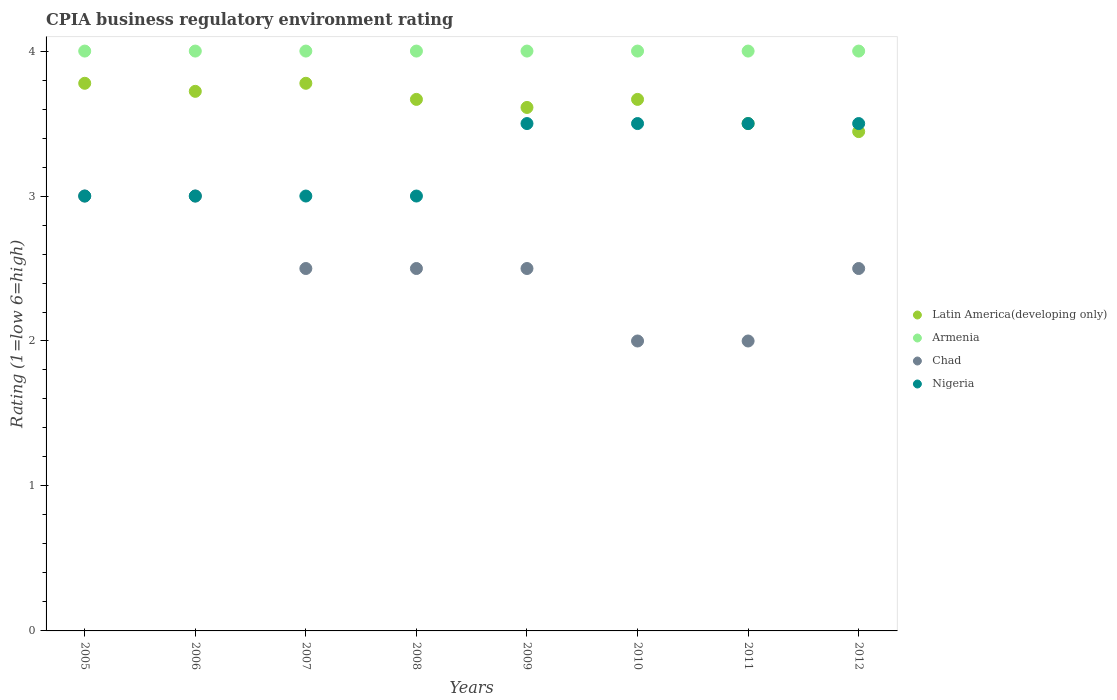What is the CPIA rating in Nigeria in 2009?
Keep it short and to the point. 3.5. Across all years, what is the maximum CPIA rating in Latin America(developing only)?
Your answer should be very brief. 3.78. In which year was the CPIA rating in Chad maximum?
Your answer should be very brief. 2005. In which year was the CPIA rating in Chad minimum?
Keep it short and to the point. 2010. What is the total CPIA rating in Latin America(developing only) in the graph?
Offer a very short reply. 29.17. What is the difference between the CPIA rating in Chad in 2007 and that in 2008?
Give a very brief answer. 0. What is the difference between the CPIA rating in Nigeria in 2011 and the CPIA rating in Armenia in 2005?
Your response must be concise. -0.5. In how many years, is the CPIA rating in Armenia greater than 3.2?
Your answer should be compact. 8. What is the difference between the highest and the second highest CPIA rating in Nigeria?
Offer a very short reply. 0. What is the difference between the highest and the lowest CPIA rating in Chad?
Provide a succinct answer. 1. In how many years, is the CPIA rating in Armenia greater than the average CPIA rating in Armenia taken over all years?
Ensure brevity in your answer.  0. Is the sum of the CPIA rating in Chad in 2008 and 2011 greater than the maximum CPIA rating in Armenia across all years?
Keep it short and to the point. Yes. Is it the case that in every year, the sum of the CPIA rating in Latin America(developing only) and CPIA rating in Armenia  is greater than the CPIA rating in Nigeria?
Your answer should be very brief. Yes. Is the CPIA rating in Chad strictly greater than the CPIA rating in Nigeria over the years?
Offer a terse response. No. Is the CPIA rating in Nigeria strictly less than the CPIA rating in Latin America(developing only) over the years?
Provide a short and direct response. No. How many dotlines are there?
Keep it short and to the point. 4. What is the difference between two consecutive major ticks on the Y-axis?
Give a very brief answer. 1. Are the values on the major ticks of Y-axis written in scientific E-notation?
Give a very brief answer. No. How are the legend labels stacked?
Your answer should be very brief. Vertical. What is the title of the graph?
Offer a terse response. CPIA business regulatory environment rating. What is the label or title of the X-axis?
Provide a short and direct response. Years. What is the Rating (1=low 6=high) in Latin America(developing only) in 2005?
Offer a terse response. 3.78. What is the Rating (1=low 6=high) of Armenia in 2005?
Keep it short and to the point. 4. What is the Rating (1=low 6=high) in Nigeria in 2005?
Ensure brevity in your answer.  3. What is the Rating (1=low 6=high) in Latin America(developing only) in 2006?
Provide a short and direct response. 3.72. What is the Rating (1=low 6=high) in Nigeria in 2006?
Make the answer very short. 3. What is the Rating (1=low 6=high) of Latin America(developing only) in 2007?
Give a very brief answer. 3.78. What is the Rating (1=low 6=high) in Chad in 2007?
Your answer should be compact. 2.5. What is the Rating (1=low 6=high) in Nigeria in 2007?
Offer a terse response. 3. What is the Rating (1=low 6=high) in Latin America(developing only) in 2008?
Provide a succinct answer. 3.67. What is the Rating (1=low 6=high) of Armenia in 2008?
Provide a succinct answer. 4. What is the Rating (1=low 6=high) in Chad in 2008?
Make the answer very short. 2.5. What is the Rating (1=low 6=high) of Latin America(developing only) in 2009?
Keep it short and to the point. 3.61. What is the Rating (1=low 6=high) in Nigeria in 2009?
Your response must be concise. 3.5. What is the Rating (1=low 6=high) in Latin America(developing only) in 2010?
Offer a very short reply. 3.67. What is the Rating (1=low 6=high) of Chad in 2010?
Provide a succinct answer. 2. What is the Rating (1=low 6=high) in Armenia in 2011?
Offer a very short reply. 4. What is the Rating (1=low 6=high) in Nigeria in 2011?
Your response must be concise. 3.5. What is the Rating (1=low 6=high) in Latin America(developing only) in 2012?
Make the answer very short. 3.44. What is the Rating (1=low 6=high) of Nigeria in 2012?
Offer a terse response. 3.5. Across all years, what is the maximum Rating (1=low 6=high) in Latin America(developing only)?
Your response must be concise. 3.78. Across all years, what is the maximum Rating (1=low 6=high) in Armenia?
Offer a very short reply. 4. Across all years, what is the maximum Rating (1=low 6=high) in Nigeria?
Give a very brief answer. 3.5. Across all years, what is the minimum Rating (1=low 6=high) of Latin America(developing only)?
Offer a very short reply. 3.44. Across all years, what is the minimum Rating (1=low 6=high) of Armenia?
Provide a short and direct response. 4. Across all years, what is the minimum Rating (1=low 6=high) in Nigeria?
Keep it short and to the point. 3. What is the total Rating (1=low 6=high) in Latin America(developing only) in the graph?
Provide a short and direct response. 29.17. What is the total Rating (1=low 6=high) in Chad in the graph?
Provide a short and direct response. 20. What is the total Rating (1=low 6=high) in Nigeria in the graph?
Offer a terse response. 26. What is the difference between the Rating (1=low 6=high) in Latin America(developing only) in 2005 and that in 2006?
Provide a short and direct response. 0.06. What is the difference between the Rating (1=low 6=high) of Armenia in 2005 and that in 2006?
Provide a succinct answer. 0. What is the difference between the Rating (1=low 6=high) in Chad in 2005 and that in 2006?
Ensure brevity in your answer.  0. What is the difference between the Rating (1=low 6=high) in Nigeria in 2005 and that in 2006?
Make the answer very short. 0. What is the difference between the Rating (1=low 6=high) of Chad in 2005 and that in 2007?
Give a very brief answer. 0.5. What is the difference between the Rating (1=low 6=high) of Armenia in 2005 and that in 2008?
Your response must be concise. 0. What is the difference between the Rating (1=low 6=high) of Nigeria in 2005 and that in 2008?
Keep it short and to the point. 0. What is the difference between the Rating (1=low 6=high) of Latin America(developing only) in 2005 and that in 2009?
Provide a succinct answer. 0.17. What is the difference between the Rating (1=low 6=high) in Chad in 2005 and that in 2009?
Offer a very short reply. 0.5. What is the difference between the Rating (1=low 6=high) of Nigeria in 2005 and that in 2009?
Your answer should be compact. -0.5. What is the difference between the Rating (1=low 6=high) of Armenia in 2005 and that in 2010?
Provide a short and direct response. 0. What is the difference between the Rating (1=low 6=high) in Nigeria in 2005 and that in 2010?
Keep it short and to the point. -0.5. What is the difference between the Rating (1=low 6=high) in Latin America(developing only) in 2005 and that in 2011?
Your answer should be very brief. 0.28. What is the difference between the Rating (1=low 6=high) of Armenia in 2005 and that in 2011?
Your answer should be compact. 0. What is the difference between the Rating (1=low 6=high) of Armenia in 2005 and that in 2012?
Offer a very short reply. 0. What is the difference between the Rating (1=low 6=high) of Chad in 2005 and that in 2012?
Your answer should be very brief. 0.5. What is the difference between the Rating (1=low 6=high) of Nigeria in 2005 and that in 2012?
Your answer should be compact. -0.5. What is the difference between the Rating (1=low 6=high) of Latin America(developing only) in 2006 and that in 2007?
Provide a short and direct response. -0.06. What is the difference between the Rating (1=low 6=high) in Latin America(developing only) in 2006 and that in 2008?
Make the answer very short. 0.06. What is the difference between the Rating (1=low 6=high) in Chad in 2006 and that in 2008?
Offer a terse response. 0.5. What is the difference between the Rating (1=low 6=high) in Latin America(developing only) in 2006 and that in 2009?
Offer a terse response. 0.11. What is the difference between the Rating (1=low 6=high) of Armenia in 2006 and that in 2009?
Make the answer very short. 0. What is the difference between the Rating (1=low 6=high) of Chad in 2006 and that in 2009?
Your answer should be very brief. 0.5. What is the difference between the Rating (1=low 6=high) of Nigeria in 2006 and that in 2009?
Your response must be concise. -0.5. What is the difference between the Rating (1=low 6=high) of Latin America(developing only) in 2006 and that in 2010?
Give a very brief answer. 0.06. What is the difference between the Rating (1=low 6=high) in Latin America(developing only) in 2006 and that in 2011?
Keep it short and to the point. 0.22. What is the difference between the Rating (1=low 6=high) in Chad in 2006 and that in 2011?
Make the answer very short. 1. What is the difference between the Rating (1=low 6=high) in Nigeria in 2006 and that in 2011?
Offer a terse response. -0.5. What is the difference between the Rating (1=low 6=high) in Latin America(developing only) in 2006 and that in 2012?
Your response must be concise. 0.28. What is the difference between the Rating (1=low 6=high) in Chad in 2006 and that in 2012?
Your answer should be compact. 0.5. What is the difference between the Rating (1=low 6=high) in Nigeria in 2006 and that in 2012?
Offer a terse response. -0.5. What is the difference between the Rating (1=low 6=high) in Latin America(developing only) in 2007 and that in 2008?
Give a very brief answer. 0.11. What is the difference between the Rating (1=low 6=high) of Latin America(developing only) in 2007 and that in 2009?
Give a very brief answer. 0.17. What is the difference between the Rating (1=low 6=high) of Armenia in 2007 and that in 2009?
Ensure brevity in your answer.  0. What is the difference between the Rating (1=low 6=high) in Armenia in 2007 and that in 2010?
Your answer should be compact. 0. What is the difference between the Rating (1=low 6=high) in Latin America(developing only) in 2007 and that in 2011?
Give a very brief answer. 0.28. What is the difference between the Rating (1=low 6=high) of Chad in 2007 and that in 2011?
Provide a short and direct response. 0.5. What is the difference between the Rating (1=low 6=high) in Nigeria in 2007 and that in 2011?
Ensure brevity in your answer.  -0.5. What is the difference between the Rating (1=low 6=high) of Armenia in 2007 and that in 2012?
Your response must be concise. 0. What is the difference between the Rating (1=low 6=high) in Latin America(developing only) in 2008 and that in 2009?
Provide a succinct answer. 0.06. What is the difference between the Rating (1=low 6=high) of Nigeria in 2008 and that in 2009?
Offer a very short reply. -0.5. What is the difference between the Rating (1=low 6=high) in Latin America(developing only) in 2008 and that in 2010?
Keep it short and to the point. 0. What is the difference between the Rating (1=low 6=high) of Chad in 2008 and that in 2010?
Your response must be concise. 0.5. What is the difference between the Rating (1=low 6=high) in Nigeria in 2008 and that in 2011?
Your response must be concise. -0.5. What is the difference between the Rating (1=low 6=high) of Latin America(developing only) in 2008 and that in 2012?
Offer a very short reply. 0.22. What is the difference between the Rating (1=low 6=high) of Armenia in 2008 and that in 2012?
Ensure brevity in your answer.  0. What is the difference between the Rating (1=low 6=high) of Chad in 2008 and that in 2012?
Provide a short and direct response. 0. What is the difference between the Rating (1=low 6=high) in Latin America(developing only) in 2009 and that in 2010?
Give a very brief answer. -0.06. What is the difference between the Rating (1=low 6=high) of Nigeria in 2009 and that in 2010?
Your response must be concise. 0. What is the difference between the Rating (1=low 6=high) of Latin America(developing only) in 2009 and that in 2012?
Offer a very short reply. 0.17. What is the difference between the Rating (1=low 6=high) of Armenia in 2009 and that in 2012?
Keep it short and to the point. 0. What is the difference between the Rating (1=low 6=high) of Chad in 2009 and that in 2012?
Give a very brief answer. 0. What is the difference between the Rating (1=low 6=high) in Armenia in 2010 and that in 2011?
Offer a very short reply. 0. What is the difference between the Rating (1=low 6=high) of Chad in 2010 and that in 2011?
Offer a terse response. 0. What is the difference between the Rating (1=low 6=high) of Nigeria in 2010 and that in 2011?
Your response must be concise. 0. What is the difference between the Rating (1=low 6=high) in Latin America(developing only) in 2010 and that in 2012?
Your answer should be very brief. 0.22. What is the difference between the Rating (1=low 6=high) in Armenia in 2010 and that in 2012?
Your answer should be very brief. 0. What is the difference between the Rating (1=low 6=high) of Chad in 2010 and that in 2012?
Offer a terse response. -0.5. What is the difference between the Rating (1=low 6=high) of Nigeria in 2010 and that in 2012?
Provide a succinct answer. 0. What is the difference between the Rating (1=low 6=high) in Latin America(developing only) in 2011 and that in 2012?
Your response must be concise. 0.06. What is the difference between the Rating (1=low 6=high) of Nigeria in 2011 and that in 2012?
Provide a succinct answer. 0. What is the difference between the Rating (1=low 6=high) in Latin America(developing only) in 2005 and the Rating (1=low 6=high) in Armenia in 2006?
Your answer should be very brief. -0.22. What is the difference between the Rating (1=low 6=high) in Armenia in 2005 and the Rating (1=low 6=high) in Chad in 2006?
Provide a short and direct response. 1. What is the difference between the Rating (1=low 6=high) of Chad in 2005 and the Rating (1=low 6=high) of Nigeria in 2006?
Offer a very short reply. 0. What is the difference between the Rating (1=low 6=high) in Latin America(developing only) in 2005 and the Rating (1=low 6=high) in Armenia in 2007?
Provide a succinct answer. -0.22. What is the difference between the Rating (1=low 6=high) in Latin America(developing only) in 2005 and the Rating (1=low 6=high) in Chad in 2007?
Provide a succinct answer. 1.28. What is the difference between the Rating (1=low 6=high) in Latin America(developing only) in 2005 and the Rating (1=low 6=high) in Nigeria in 2007?
Offer a very short reply. 0.78. What is the difference between the Rating (1=low 6=high) in Armenia in 2005 and the Rating (1=low 6=high) in Chad in 2007?
Your response must be concise. 1.5. What is the difference between the Rating (1=low 6=high) of Armenia in 2005 and the Rating (1=low 6=high) of Nigeria in 2007?
Keep it short and to the point. 1. What is the difference between the Rating (1=low 6=high) of Latin America(developing only) in 2005 and the Rating (1=low 6=high) of Armenia in 2008?
Keep it short and to the point. -0.22. What is the difference between the Rating (1=low 6=high) of Latin America(developing only) in 2005 and the Rating (1=low 6=high) of Chad in 2008?
Give a very brief answer. 1.28. What is the difference between the Rating (1=low 6=high) in Latin America(developing only) in 2005 and the Rating (1=low 6=high) in Nigeria in 2008?
Offer a very short reply. 0.78. What is the difference between the Rating (1=low 6=high) of Armenia in 2005 and the Rating (1=low 6=high) of Chad in 2008?
Keep it short and to the point. 1.5. What is the difference between the Rating (1=low 6=high) of Latin America(developing only) in 2005 and the Rating (1=low 6=high) of Armenia in 2009?
Ensure brevity in your answer.  -0.22. What is the difference between the Rating (1=low 6=high) of Latin America(developing only) in 2005 and the Rating (1=low 6=high) of Chad in 2009?
Provide a short and direct response. 1.28. What is the difference between the Rating (1=low 6=high) of Latin America(developing only) in 2005 and the Rating (1=low 6=high) of Nigeria in 2009?
Your answer should be very brief. 0.28. What is the difference between the Rating (1=low 6=high) of Armenia in 2005 and the Rating (1=low 6=high) of Chad in 2009?
Keep it short and to the point. 1.5. What is the difference between the Rating (1=low 6=high) in Chad in 2005 and the Rating (1=low 6=high) in Nigeria in 2009?
Give a very brief answer. -0.5. What is the difference between the Rating (1=low 6=high) in Latin America(developing only) in 2005 and the Rating (1=low 6=high) in Armenia in 2010?
Keep it short and to the point. -0.22. What is the difference between the Rating (1=low 6=high) of Latin America(developing only) in 2005 and the Rating (1=low 6=high) of Chad in 2010?
Your answer should be compact. 1.78. What is the difference between the Rating (1=low 6=high) of Latin America(developing only) in 2005 and the Rating (1=low 6=high) of Nigeria in 2010?
Your answer should be compact. 0.28. What is the difference between the Rating (1=low 6=high) of Armenia in 2005 and the Rating (1=low 6=high) of Chad in 2010?
Keep it short and to the point. 2. What is the difference between the Rating (1=low 6=high) in Latin America(developing only) in 2005 and the Rating (1=low 6=high) in Armenia in 2011?
Offer a very short reply. -0.22. What is the difference between the Rating (1=low 6=high) in Latin America(developing only) in 2005 and the Rating (1=low 6=high) in Chad in 2011?
Provide a short and direct response. 1.78. What is the difference between the Rating (1=low 6=high) of Latin America(developing only) in 2005 and the Rating (1=low 6=high) of Nigeria in 2011?
Make the answer very short. 0.28. What is the difference between the Rating (1=low 6=high) of Armenia in 2005 and the Rating (1=low 6=high) of Chad in 2011?
Provide a succinct answer. 2. What is the difference between the Rating (1=low 6=high) in Chad in 2005 and the Rating (1=low 6=high) in Nigeria in 2011?
Keep it short and to the point. -0.5. What is the difference between the Rating (1=low 6=high) of Latin America(developing only) in 2005 and the Rating (1=low 6=high) of Armenia in 2012?
Offer a terse response. -0.22. What is the difference between the Rating (1=low 6=high) in Latin America(developing only) in 2005 and the Rating (1=low 6=high) in Chad in 2012?
Offer a terse response. 1.28. What is the difference between the Rating (1=low 6=high) of Latin America(developing only) in 2005 and the Rating (1=low 6=high) of Nigeria in 2012?
Your answer should be compact. 0.28. What is the difference between the Rating (1=low 6=high) in Armenia in 2005 and the Rating (1=low 6=high) in Chad in 2012?
Give a very brief answer. 1.5. What is the difference between the Rating (1=low 6=high) of Armenia in 2005 and the Rating (1=low 6=high) of Nigeria in 2012?
Your answer should be very brief. 0.5. What is the difference between the Rating (1=low 6=high) of Chad in 2005 and the Rating (1=low 6=high) of Nigeria in 2012?
Offer a very short reply. -0.5. What is the difference between the Rating (1=low 6=high) in Latin America(developing only) in 2006 and the Rating (1=low 6=high) in Armenia in 2007?
Your answer should be very brief. -0.28. What is the difference between the Rating (1=low 6=high) of Latin America(developing only) in 2006 and the Rating (1=low 6=high) of Chad in 2007?
Provide a succinct answer. 1.22. What is the difference between the Rating (1=low 6=high) in Latin America(developing only) in 2006 and the Rating (1=low 6=high) in Nigeria in 2007?
Offer a terse response. 0.72. What is the difference between the Rating (1=low 6=high) in Armenia in 2006 and the Rating (1=low 6=high) in Nigeria in 2007?
Your answer should be very brief. 1. What is the difference between the Rating (1=low 6=high) in Latin America(developing only) in 2006 and the Rating (1=low 6=high) in Armenia in 2008?
Provide a short and direct response. -0.28. What is the difference between the Rating (1=low 6=high) of Latin America(developing only) in 2006 and the Rating (1=low 6=high) of Chad in 2008?
Ensure brevity in your answer.  1.22. What is the difference between the Rating (1=low 6=high) in Latin America(developing only) in 2006 and the Rating (1=low 6=high) in Nigeria in 2008?
Your answer should be very brief. 0.72. What is the difference between the Rating (1=low 6=high) of Armenia in 2006 and the Rating (1=low 6=high) of Chad in 2008?
Make the answer very short. 1.5. What is the difference between the Rating (1=low 6=high) in Latin America(developing only) in 2006 and the Rating (1=low 6=high) in Armenia in 2009?
Provide a short and direct response. -0.28. What is the difference between the Rating (1=low 6=high) in Latin America(developing only) in 2006 and the Rating (1=low 6=high) in Chad in 2009?
Make the answer very short. 1.22. What is the difference between the Rating (1=low 6=high) in Latin America(developing only) in 2006 and the Rating (1=low 6=high) in Nigeria in 2009?
Give a very brief answer. 0.22. What is the difference between the Rating (1=low 6=high) of Chad in 2006 and the Rating (1=low 6=high) of Nigeria in 2009?
Offer a terse response. -0.5. What is the difference between the Rating (1=low 6=high) in Latin America(developing only) in 2006 and the Rating (1=low 6=high) in Armenia in 2010?
Provide a succinct answer. -0.28. What is the difference between the Rating (1=low 6=high) in Latin America(developing only) in 2006 and the Rating (1=low 6=high) in Chad in 2010?
Provide a succinct answer. 1.72. What is the difference between the Rating (1=low 6=high) in Latin America(developing only) in 2006 and the Rating (1=low 6=high) in Nigeria in 2010?
Keep it short and to the point. 0.22. What is the difference between the Rating (1=low 6=high) of Chad in 2006 and the Rating (1=low 6=high) of Nigeria in 2010?
Your response must be concise. -0.5. What is the difference between the Rating (1=low 6=high) of Latin America(developing only) in 2006 and the Rating (1=low 6=high) of Armenia in 2011?
Your response must be concise. -0.28. What is the difference between the Rating (1=low 6=high) of Latin America(developing only) in 2006 and the Rating (1=low 6=high) of Chad in 2011?
Offer a very short reply. 1.72. What is the difference between the Rating (1=low 6=high) of Latin America(developing only) in 2006 and the Rating (1=low 6=high) of Nigeria in 2011?
Give a very brief answer. 0.22. What is the difference between the Rating (1=low 6=high) of Armenia in 2006 and the Rating (1=low 6=high) of Chad in 2011?
Your answer should be compact. 2. What is the difference between the Rating (1=low 6=high) of Latin America(developing only) in 2006 and the Rating (1=low 6=high) of Armenia in 2012?
Provide a succinct answer. -0.28. What is the difference between the Rating (1=low 6=high) in Latin America(developing only) in 2006 and the Rating (1=low 6=high) in Chad in 2012?
Make the answer very short. 1.22. What is the difference between the Rating (1=low 6=high) in Latin America(developing only) in 2006 and the Rating (1=low 6=high) in Nigeria in 2012?
Ensure brevity in your answer.  0.22. What is the difference between the Rating (1=low 6=high) of Armenia in 2006 and the Rating (1=low 6=high) of Chad in 2012?
Your answer should be very brief. 1.5. What is the difference between the Rating (1=low 6=high) of Chad in 2006 and the Rating (1=low 6=high) of Nigeria in 2012?
Offer a very short reply. -0.5. What is the difference between the Rating (1=low 6=high) of Latin America(developing only) in 2007 and the Rating (1=low 6=high) of Armenia in 2008?
Offer a very short reply. -0.22. What is the difference between the Rating (1=low 6=high) of Latin America(developing only) in 2007 and the Rating (1=low 6=high) of Chad in 2008?
Provide a succinct answer. 1.28. What is the difference between the Rating (1=low 6=high) in Latin America(developing only) in 2007 and the Rating (1=low 6=high) in Nigeria in 2008?
Make the answer very short. 0.78. What is the difference between the Rating (1=low 6=high) in Armenia in 2007 and the Rating (1=low 6=high) in Nigeria in 2008?
Ensure brevity in your answer.  1. What is the difference between the Rating (1=low 6=high) in Latin America(developing only) in 2007 and the Rating (1=low 6=high) in Armenia in 2009?
Your answer should be very brief. -0.22. What is the difference between the Rating (1=low 6=high) in Latin America(developing only) in 2007 and the Rating (1=low 6=high) in Chad in 2009?
Make the answer very short. 1.28. What is the difference between the Rating (1=low 6=high) in Latin America(developing only) in 2007 and the Rating (1=low 6=high) in Nigeria in 2009?
Your answer should be compact. 0.28. What is the difference between the Rating (1=low 6=high) in Armenia in 2007 and the Rating (1=low 6=high) in Nigeria in 2009?
Provide a short and direct response. 0.5. What is the difference between the Rating (1=low 6=high) in Latin America(developing only) in 2007 and the Rating (1=low 6=high) in Armenia in 2010?
Your response must be concise. -0.22. What is the difference between the Rating (1=low 6=high) of Latin America(developing only) in 2007 and the Rating (1=low 6=high) of Chad in 2010?
Your answer should be very brief. 1.78. What is the difference between the Rating (1=low 6=high) in Latin America(developing only) in 2007 and the Rating (1=low 6=high) in Nigeria in 2010?
Your answer should be compact. 0.28. What is the difference between the Rating (1=low 6=high) in Chad in 2007 and the Rating (1=low 6=high) in Nigeria in 2010?
Keep it short and to the point. -1. What is the difference between the Rating (1=low 6=high) in Latin America(developing only) in 2007 and the Rating (1=low 6=high) in Armenia in 2011?
Provide a succinct answer. -0.22. What is the difference between the Rating (1=low 6=high) of Latin America(developing only) in 2007 and the Rating (1=low 6=high) of Chad in 2011?
Provide a short and direct response. 1.78. What is the difference between the Rating (1=low 6=high) in Latin America(developing only) in 2007 and the Rating (1=low 6=high) in Nigeria in 2011?
Provide a short and direct response. 0.28. What is the difference between the Rating (1=low 6=high) of Armenia in 2007 and the Rating (1=low 6=high) of Chad in 2011?
Provide a short and direct response. 2. What is the difference between the Rating (1=low 6=high) in Chad in 2007 and the Rating (1=low 6=high) in Nigeria in 2011?
Offer a very short reply. -1. What is the difference between the Rating (1=low 6=high) in Latin America(developing only) in 2007 and the Rating (1=low 6=high) in Armenia in 2012?
Your response must be concise. -0.22. What is the difference between the Rating (1=low 6=high) of Latin America(developing only) in 2007 and the Rating (1=low 6=high) of Chad in 2012?
Provide a short and direct response. 1.28. What is the difference between the Rating (1=low 6=high) of Latin America(developing only) in 2007 and the Rating (1=low 6=high) of Nigeria in 2012?
Offer a very short reply. 0.28. What is the difference between the Rating (1=low 6=high) of Armenia in 2007 and the Rating (1=low 6=high) of Chad in 2012?
Make the answer very short. 1.5. What is the difference between the Rating (1=low 6=high) in Armenia in 2007 and the Rating (1=low 6=high) in Nigeria in 2012?
Your answer should be compact. 0.5. What is the difference between the Rating (1=low 6=high) of Chad in 2007 and the Rating (1=low 6=high) of Nigeria in 2012?
Your answer should be compact. -1. What is the difference between the Rating (1=low 6=high) in Latin America(developing only) in 2008 and the Rating (1=low 6=high) in Nigeria in 2009?
Provide a short and direct response. 0.17. What is the difference between the Rating (1=low 6=high) of Armenia in 2008 and the Rating (1=low 6=high) of Nigeria in 2009?
Provide a short and direct response. 0.5. What is the difference between the Rating (1=low 6=high) in Latin America(developing only) in 2008 and the Rating (1=low 6=high) in Armenia in 2010?
Provide a succinct answer. -0.33. What is the difference between the Rating (1=low 6=high) of Armenia in 2008 and the Rating (1=low 6=high) of Chad in 2010?
Provide a short and direct response. 2. What is the difference between the Rating (1=low 6=high) in Armenia in 2008 and the Rating (1=low 6=high) in Nigeria in 2010?
Offer a terse response. 0.5. What is the difference between the Rating (1=low 6=high) of Chad in 2008 and the Rating (1=low 6=high) of Nigeria in 2010?
Provide a short and direct response. -1. What is the difference between the Rating (1=low 6=high) of Latin America(developing only) in 2008 and the Rating (1=low 6=high) of Armenia in 2011?
Offer a very short reply. -0.33. What is the difference between the Rating (1=low 6=high) in Latin America(developing only) in 2008 and the Rating (1=low 6=high) in Nigeria in 2011?
Keep it short and to the point. 0.17. What is the difference between the Rating (1=low 6=high) of Chad in 2008 and the Rating (1=low 6=high) of Nigeria in 2011?
Offer a terse response. -1. What is the difference between the Rating (1=low 6=high) of Latin America(developing only) in 2008 and the Rating (1=low 6=high) of Armenia in 2012?
Give a very brief answer. -0.33. What is the difference between the Rating (1=low 6=high) of Latin America(developing only) in 2008 and the Rating (1=low 6=high) of Nigeria in 2012?
Your response must be concise. 0.17. What is the difference between the Rating (1=low 6=high) in Chad in 2008 and the Rating (1=low 6=high) in Nigeria in 2012?
Your answer should be very brief. -1. What is the difference between the Rating (1=low 6=high) in Latin America(developing only) in 2009 and the Rating (1=low 6=high) in Armenia in 2010?
Give a very brief answer. -0.39. What is the difference between the Rating (1=low 6=high) in Latin America(developing only) in 2009 and the Rating (1=low 6=high) in Chad in 2010?
Offer a very short reply. 1.61. What is the difference between the Rating (1=low 6=high) in Latin America(developing only) in 2009 and the Rating (1=low 6=high) in Nigeria in 2010?
Provide a succinct answer. 0.11. What is the difference between the Rating (1=low 6=high) in Armenia in 2009 and the Rating (1=low 6=high) in Chad in 2010?
Your response must be concise. 2. What is the difference between the Rating (1=low 6=high) of Latin America(developing only) in 2009 and the Rating (1=low 6=high) of Armenia in 2011?
Offer a terse response. -0.39. What is the difference between the Rating (1=low 6=high) of Latin America(developing only) in 2009 and the Rating (1=low 6=high) of Chad in 2011?
Make the answer very short. 1.61. What is the difference between the Rating (1=low 6=high) in Latin America(developing only) in 2009 and the Rating (1=low 6=high) in Nigeria in 2011?
Offer a very short reply. 0.11. What is the difference between the Rating (1=low 6=high) of Chad in 2009 and the Rating (1=low 6=high) of Nigeria in 2011?
Provide a short and direct response. -1. What is the difference between the Rating (1=low 6=high) in Latin America(developing only) in 2009 and the Rating (1=low 6=high) in Armenia in 2012?
Your answer should be very brief. -0.39. What is the difference between the Rating (1=low 6=high) in Latin America(developing only) in 2009 and the Rating (1=low 6=high) in Nigeria in 2012?
Make the answer very short. 0.11. What is the difference between the Rating (1=low 6=high) of Chad in 2009 and the Rating (1=low 6=high) of Nigeria in 2012?
Your answer should be compact. -1. What is the difference between the Rating (1=low 6=high) in Armenia in 2010 and the Rating (1=low 6=high) in Chad in 2011?
Make the answer very short. 2. What is the difference between the Rating (1=low 6=high) of Armenia in 2010 and the Rating (1=low 6=high) of Nigeria in 2011?
Ensure brevity in your answer.  0.5. What is the difference between the Rating (1=low 6=high) in Latin America(developing only) in 2010 and the Rating (1=low 6=high) in Armenia in 2012?
Provide a succinct answer. -0.33. What is the difference between the Rating (1=low 6=high) of Latin America(developing only) in 2010 and the Rating (1=low 6=high) of Chad in 2012?
Your response must be concise. 1.17. What is the difference between the Rating (1=low 6=high) of Latin America(developing only) in 2010 and the Rating (1=low 6=high) of Nigeria in 2012?
Ensure brevity in your answer.  0.17. What is the difference between the Rating (1=low 6=high) in Chad in 2010 and the Rating (1=low 6=high) in Nigeria in 2012?
Your answer should be very brief. -1.5. What is the difference between the Rating (1=low 6=high) of Chad in 2011 and the Rating (1=low 6=high) of Nigeria in 2012?
Your response must be concise. -1.5. What is the average Rating (1=low 6=high) in Latin America(developing only) per year?
Keep it short and to the point. 3.65. What is the average Rating (1=low 6=high) in Chad per year?
Offer a very short reply. 2.5. What is the average Rating (1=low 6=high) in Nigeria per year?
Make the answer very short. 3.25. In the year 2005, what is the difference between the Rating (1=low 6=high) in Latin America(developing only) and Rating (1=low 6=high) in Armenia?
Offer a very short reply. -0.22. In the year 2005, what is the difference between the Rating (1=low 6=high) of Armenia and Rating (1=low 6=high) of Chad?
Provide a succinct answer. 1. In the year 2005, what is the difference between the Rating (1=low 6=high) in Armenia and Rating (1=low 6=high) in Nigeria?
Make the answer very short. 1. In the year 2006, what is the difference between the Rating (1=low 6=high) in Latin America(developing only) and Rating (1=low 6=high) in Armenia?
Provide a succinct answer. -0.28. In the year 2006, what is the difference between the Rating (1=low 6=high) in Latin America(developing only) and Rating (1=low 6=high) in Chad?
Ensure brevity in your answer.  0.72. In the year 2006, what is the difference between the Rating (1=low 6=high) of Latin America(developing only) and Rating (1=low 6=high) of Nigeria?
Keep it short and to the point. 0.72. In the year 2006, what is the difference between the Rating (1=low 6=high) of Armenia and Rating (1=low 6=high) of Chad?
Offer a very short reply. 1. In the year 2006, what is the difference between the Rating (1=low 6=high) in Chad and Rating (1=low 6=high) in Nigeria?
Provide a succinct answer. 0. In the year 2007, what is the difference between the Rating (1=low 6=high) in Latin America(developing only) and Rating (1=low 6=high) in Armenia?
Your response must be concise. -0.22. In the year 2007, what is the difference between the Rating (1=low 6=high) of Latin America(developing only) and Rating (1=low 6=high) of Chad?
Your answer should be very brief. 1.28. In the year 2007, what is the difference between the Rating (1=low 6=high) of Latin America(developing only) and Rating (1=low 6=high) of Nigeria?
Your response must be concise. 0.78. In the year 2007, what is the difference between the Rating (1=low 6=high) of Armenia and Rating (1=low 6=high) of Chad?
Give a very brief answer. 1.5. In the year 2007, what is the difference between the Rating (1=low 6=high) of Chad and Rating (1=low 6=high) of Nigeria?
Offer a very short reply. -0.5. In the year 2008, what is the difference between the Rating (1=low 6=high) in Latin America(developing only) and Rating (1=low 6=high) in Chad?
Make the answer very short. 1.17. In the year 2008, what is the difference between the Rating (1=low 6=high) in Armenia and Rating (1=low 6=high) in Chad?
Offer a very short reply. 1.5. In the year 2008, what is the difference between the Rating (1=low 6=high) of Armenia and Rating (1=low 6=high) of Nigeria?
Your response must be concise. 1. In the year 2009, what is the difference between the Rating (1=low 6=high) in Latin America(developing only) and Rating (1=low 6=high) in Armenia?
Your answer should be very brief. -0.39. In the year 2009, what is the difference between the Rating (1=low 6=high) in Latin America(developing only) and Rating (1=low 6=high) in Nigeria?
Provide a succinct answer. 0.11. In the year 2009, what is the difference between the Rating (1=low 6=high) in Chad and Rating (1=low 6=high) in Nigeria?
Your answer should be very brief. -1. In the year 2010, what is the difference between the Rating (1=low 6=high) in Latin America(developing only) and Rating (1=low 6=high) in Chad?
Ensure brevity in your answer.  1.67. In the year 2010, what is the difference between the Rating (1=low 6=high) in Chad and Rating (1=low 6=high) in Nigeria?
Keep it short and to the point. -1.5. In the year 2011, what is the difference between the Rating (1=low 6=high) in Latin America(developing only) and Rating (1=low 6=high) in Armenia?
Keep it short and to the point. -0.5. In the year 2011, what is the difference between the Rating (1=low 6=high) in Latin America(developing only) and Rating (1=low 6=high) in Chad?
Provide a succinct answer. 1.5. In the year 2011, what is the difference between the Rating (1=low 6=high) in Chad and Rating (1=low 6=high) in Nigeria?
Make the answer very short. -1.5. In the year 2012, what is the difference between the Rating (1=low 6=high) in Latin America(developing only) and Rating (1=low 6=high) in Armenia?
Offer a terse response. -0.56. In the year 2012, what is the difference between the Rating (1=low 6=high) of Latin America(developing only) and Rating (1=low 6=high) of Nigeria?
Give a very brief answer. -0.06. In the year 2012, what is the difference between the Rating (1=low 6=high) in Armenia and Rating (1=low 6=high) in Chad?
Your response must be concise. 1.5. In the year 2012, what is the difference between the Rating (1=low 6=high) in Armenia and Rating (1=low 6=high) in Nigeria?
Keep it short and to the point. 0.5. What is the ratio of the Rating (1=low 6=high) in Latin America(developing only) in 2005 to that in 2006?
Make the answer very short. 1.01. What is the ratio of the Rating (1=low 6=high) of Chad in 2005 to that in 2006?
Offer a very short reply. 1. What is the ratio of the Rating (1=low 6=high) in Nigeria in 2005 to that in 2006?
Ensure brevity in your answer.  1. What is the ratio of the Rating (1=low 6=high) of Latin America(developing only) in 2005 to that in 2007?
Provide a succinct answer. 1. What is the ratio of the Rating (1=low 6=high) in Latin America(developing only) in 2005 to that in 2008?
Offer a terse response. 1.03. What is the ratio of the Rating (1=low 6=high) in Chad in 2005 to that in 2008?
Make the answer very short. 1.2. What is the ratio of the Rating (1=low 6=high) in Latin America(developing only) in 2005 to that in 2009?
Your answer should be very brief. 1.05. What is the ratio of the Rating (1=low 6=high) in Armenia in 2005 to that in 2009?
Ensure brevity in your answer.  1. What is the ratio of the Rating (1=low 6=high) in Latin America(developing only) in 2005 to that in 2010?
Offer a terse response. 1.03. What is the ratio of the Rating (1=low 6=high) in Armenia in 2005 to that in 2010?
Offer a terse response. 1. What is the ratio of the Rating (1=low 6=high) in Nigeria in 2005 to that in 2010?
Offer a very short reply. 0.86. What is the ratio of the Rating (1=low 6=high) in Latin America(developing only) in 2005 to that in 2011?
Provide a short and direct response. 1.08. What is the ratio of the Rating (1=low 6=high) in Armenia in 2005 to that in 2011?
Offer a terse response. 1. What is the ratio of the Rating (1=low 6=high) in Nigeria in 2005 to that in 2011?
Keep it short and to the point. 0.86. What is the ratio of the Rating (1=low 6=high) of Latin America(developing only) in 2005 to that in 2012?
Keep it short and to the point. 1.1. What is the ratio of the Rating (1=low 6=high) of Armenia in 2005 to that in 2012?
Ensure brevity in your answer.  1. What is the ratio of the Rating (1=low 6=high) of Chad in 2005 to that in 2012?
Ensure brevity in your answer.  1.2. What is the ratio of the Rating (1=low 6=high) of Nigeria in 2005 to that in 2012?
Provide a succinct answer. 0.86. What is the ratio of the Rating (1=low 6=high) of Latin America(developing only) in 2006 to that in 2007?
Provide a short and direct response. 0.99. What is the ratio of the Rating (1=low 6=high) in Armenia in 2006 to that in 2007?
Ensure brevity in your answer.  1. What is the ratio of the Rating (1=low 6=high) of Chad in 2006 to that in 2007?
Provide a short and direct response. 1.2. What is the ratio of the Rating (1=low 6=high) of Latin America(developing only) in 2006 to that in 2008?
Your answer should be very brief. 1.02. What is the ratio of the Rating (1=low 6=high) of Armenia in 2006 to that in 2008?
Offer a very short reply. 1. What is the ratio of the Rating (1=low 6=high) of Latin America(developing only) in 2006 to that in 2009?
Ensure brevity in your answer.  1.03. What is the ratio of the Rating (1=low 6=high) of Chad in 2006 to that in 2009?
Your response must be concise. 1.2. What is the ratio of the Rating (1=low 6=high) of Latin America(developing only) in 2006 to that in 2010?
Your response must be concise. 1.02. What is the ratio of the Rating (1=low 6=high) of Armenia in 2006 to that in 2010?
Keep it short and to the point. 1. What is the ratio of the Rating (1=low 6=high) in Chad in 2006 to that in 2010?
Ensure brevity in your answer.  1.5. What is the ratio of the Rating (1=low 6=high) of Latin America(developing only) in 2006 to that in 2011?
Your response must be concise. 1.06. What is the ratio of the Rating (1=low 6=high) of Armenia in 2006 to that in 2011?
Keep it short and to the point. 1. What is the ratio of the Rating (1=low 6=high) of Nigeria in 2006 to that in 2011?
Make the answer very short. 0.86. What is the ratio of the Rating (1=low 6=high) in Latin America(developing only) in 2006 to that in 2012?
Provide a short and direct response. 1.08. What is the ratio of the Rating (1=low 6=high) of Armenia in 2006 to that in 2012?
Keep it short and to the point. 1. What is the ratio of the Rating (1=low 6=high) of Latin America(developing only) in 2007 to that in 2008?
Ensure brevity in your answer.  1.03. What is the ratio of the Rating (1=low 6=high) in Nigeria in 2007 to that in 2008?
Your response must be concise. 1. What is the ratio of the Rating (1=low 6=high) of Latin America(developing only) in 2007 to that in 2009?
Offer a terse response. 1.05. What is the ratio of the Rating (1=low 6=high) in Nigeria in 2007 to that in 2009?
Provide a succinct answer. 0.86. What is the ratio of the Rating (1=low 6=high) of Latin America(developing only) in 2007 to that in 2010?
Your answer should be compact. 1.03. What is the ratio of the Rating (1=low 6=high) in Chad in 2007 to that in 2010?
Your answer should be very brief. 1.25. What is the ratio of the Rating (1=low 6=high) in Latin America(developing only) in 2007 to that in 2011?
Give a very brief answer. 1.08. What is the ratio of the Rating (1=low 6=high) of Chad in 2007 to that in 2011?
Make the answer very short. 1.25. What is the ratio of the Rating (1=low 6=high) in Nigeria in 2007 to that in 2011?
Give a very brief answer. 0.86. What is the ratio of the Rating (1=low 6=high) in Latin America(developing only) in 2007 to that in 2012?
Offer a terse response. 1.1. What is the ratio of the Rating (1=low 6=high) in Chad in 2007 to that in 2012?
Your response must be concise. 1. What is the ratio of the Rating (1=low 6=high) in Nigeria in 2007 to that in 2012?
Provide a succinct answer. 0.86. What is the ratio of the Rating (1=low 6=high) of Latin America(developing only) in 2008 to that in 2009?
Ensure brevity in your answer.  1.02. What is the ratio of the Rating (1=low 6=high) of Armenia in 2008 to that in 2009?
Provide a succinct answer. 1. What is the ratio of the Rating (1=low 6=high) of Chad in 2008 to that in 2009?
Keep it short and to the point. 1. What is the ratio of the Rating (1=low 6=high) of Nigeria in 2008 to that in 2009?
Provide a short and direct response. 0.86. What is the ratio of the Rating (1=low 6=high) in Armenia in 2008 to that in 2010?
Provide a short and direct response. 1. What is the ratio of the Rating (1=low 6=high) of Chad in 2008 to that in 2010?
Make the answer very short. 1.25. What is the ratio of the Rating (1=low 6=high) of Latin America(developing only) in 2008 to that in 2011?
Your answer should be compact. 1.05. What is the ratio of the Rating (1=low 6=high) in Chad in 2008 to that in 2011?
Your answer should be compact. 1.25. What is the ratio of the Rating (1=low 6=high) in Latin America(developing only) in 2008 to that in 2012?
Keep it short and to the point. 1.06. What is the ratio of the Rating (1=low 6=high) of Armenia in 2008 to that in 2012?
Ensure brevity in your answer.  1. What is the ratio of the Rating (1=low 6=high) of Nigeria in 2009 to that in 2010?
Ensure brevity in your answer.  1. What is the ratio of the Rating (1=low 6=high) of Latin America(developing only) in 2009 to that in 2011?
Your answer should be very brief. 1.03. What is the ratio of the Rating (1=low 6=high) in Armenia in 2009 to that in 2011?
Give a very brief answer. 1. What is the ratio of the Rating (1=low 6=high) in Chad in 2009 to that in 2011?
Provide a short and direct response. 1.25. What is the ratio of the Rating (1=low 6=high) of Latin America(developing only) in 2009 to that in 2012?
Keep it short and to the point. 1.05. What is the ratio of the Rating (1=low 6=high) in Armenia in 2009 to that in 2012?
Ensure brevity in your answer.  1. What is the ratio of the Rating (1=low 6=high) of Latin America(developing only) in 2010 to that in 2011?
Your response must be concise. 1.05. What is the ratio of the Rating (1=low 6=high) in Nigeria in 2010 to that in 2011?
Your answer should be compact. 1. What is the ratio of the Rating (1=low 6=high) of Latin America(developing only) in 2010 to that in 2012?
Ensure brevity in your answer.  1.06. What is the ratio of the Rating (1=low 6=high) in Chad in 2010 to that in 2012?
Your answer should be compact. 0.8. What is the ratio of the Rating (1=low 6=high) of Nigeria in 2010 to that in 2012?
Offer a very short reply. 1. What is the ratio of the Rating (1=low 6=high) in Latin America(developing only) in 2011 to that in 2012?
Make the answer very short. 1.02. What is the ratio of the Rating (1=low 6=high) in Armenia in 2011 to that in 2012?
Your answer should be very brief. 1. What is the ratio of the Rating (1=low 6=high) of Chad in 2011 to that in 2012?
Offer a terse response. 0.8. What is the difference between the highest and the second highest Rating (1=low 6=high) of Latin America(developing only)?
Keep it short and to the point. 0. What is the difference between the highest and the second highest Rating (1=low 6=high) of Nigeria?
Keep it short and to the point. 0. What is the difference between the highest and the lowest Rating (1=low 6=high) in Armenia?
Offer a terse response. 0. What is the difference between the highest and the lowest Rating (1=low 6=high) of Chad?
Keep it short and to the point. 1. What is the difference between the highest and the lowest Rating (1=low 6=high) of Nigeria?
Your answer should be compact. 0.5. 